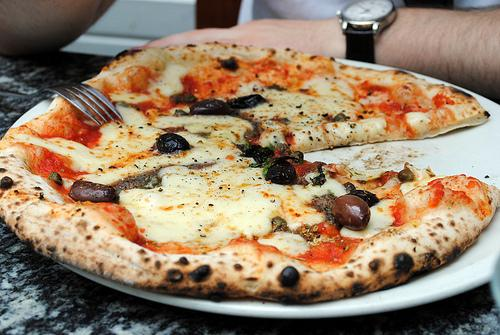Identify an accessory on a person and what it looks like. There is a black watch on a man's wrist with a silver strap and a circular face. Describe the type of surface the main subjects are placed upon. The pizza, plate, and fork are placed on a dark granite counter top, which appears to be made of marble. Comment on the presence and appearance of cheese on the pizza. There is melted cheese on the pizza, covering a portion of the surface in a gooey and stringy texture. State the number of black olives visible on the pizza and describe their appearance. A whole Kalamata olive is seen on the pizza, black in color and with a round shape. What kind of food is seen in the image and what is a noticeable characteristic about it? There is a pizza with one piece missing, having toppings like olives, melted cheese, and green spices, along with burnt spots on the crust. What is the color of the man's shirt in the image? The man is wearing a white shirt. Explain the state of the pizza crust and how it contributes to the overall image. The pizza crust is brown in color and has burnt spots, giving the image a sense of authenticity and a freshly baked, slightly overcooked look. Mention one unusual element in the image and why it stands out. A hairy elbow of a man is visible, which stands out because it seems unrelated to the main focus, which is about the pizza and its toppings. Briefly describe the plate and cutlery featured in the image. There is a white porcelain plate with a silver fork resting on it, both placed on a dark granite counter top. Please give a brief summary of the image content. The image shows a pizza with various toppings on a white plate, a silver fork, a man with a black watch, and a dark granite counter top. Compose a description of the pizza and its surrounding objects in the image. A toasted pizza with olives, cheese, and spices on a white plate with a silver fork Create a sentence describing the man's arm in the image. A hairy elbow of a man is visible. What is under the plate in the image? Table What color is the man's shirt in the image? White Describe the type of watch on the person's wrist in the image. Black watch What type of food is shown in the image with a piece missing? Pizza Provide a concise description of the pizza in the image. Pizza with olives, cheese, green spices, and a piece missing What is the condition of the pizza crust in the image? Brown and burnt in some spots What piece of cutlery is found on the plate with the pizza? Silver fork What common pizza ingredient is found alongside the black olives? Melted cheese State whether there are seasonings on the pizza. Yes, there are seasonings. Is the watch on the man's wrist black or silver? Black Identify any burnt areas on the pizza. Burnt spots on crust What type of olives are on the pizza? Kalamata olives What all is resting on the plate besides the pizza? A silver fork Enumerate the toppings on the pizza. Black olive, melted cheese, green spices, tomato sauce Explain the appearance of the pizza in the image using a short phrase. Toasted pan pizza What type of material is the counter top made of? Dark granite 